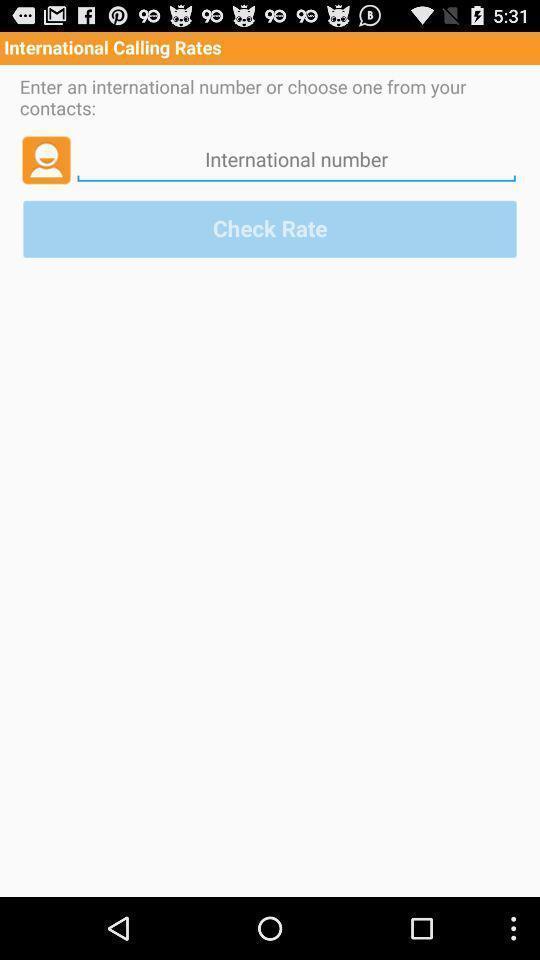Please provide a description for this image. Page showing international number on app. 